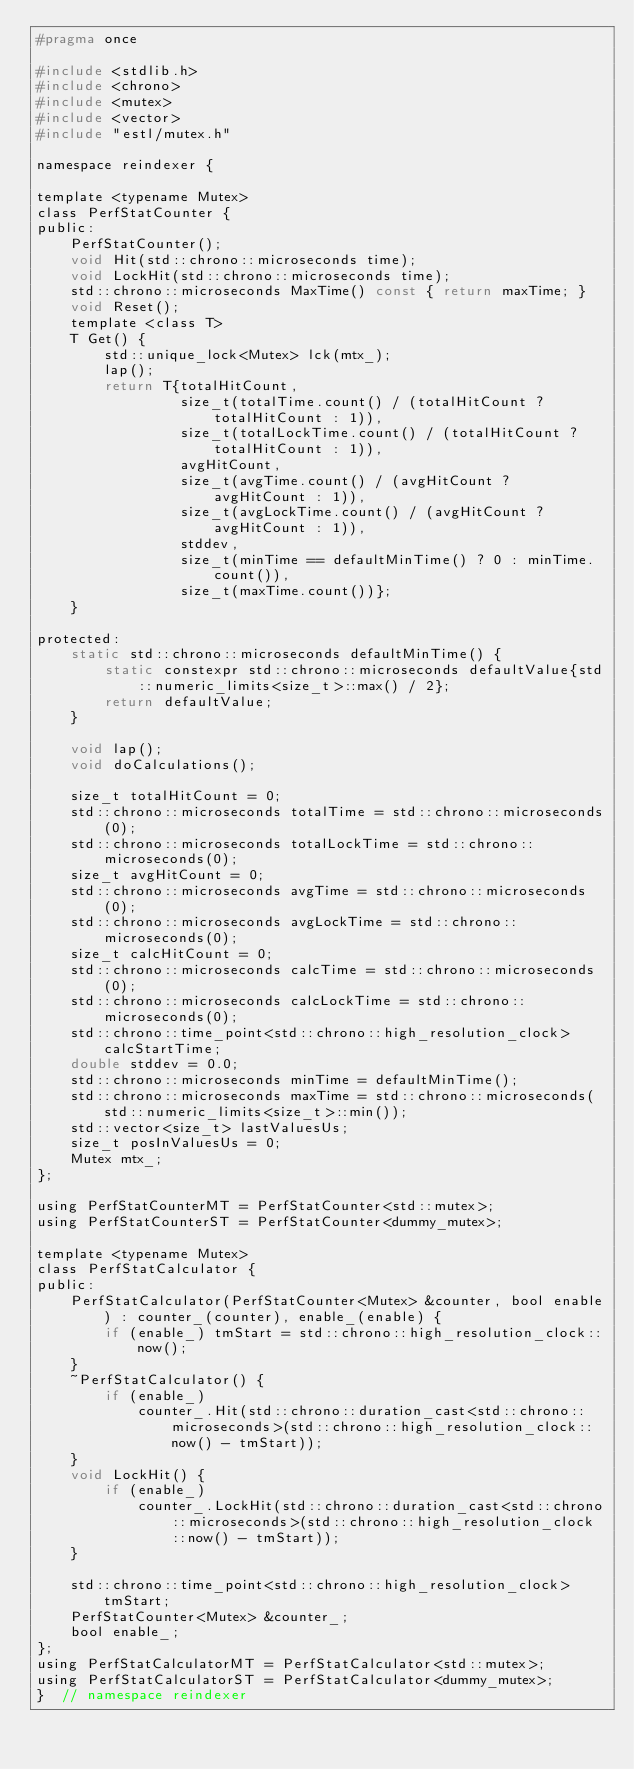Convert code to text. <code><loc_0><loc_0><loc_500><loc_500><_C_>#pragma once

#include <stdlib.h>
#include <chrono>
#include <mutex>
#include <vector>
#include "estl/mutex.h"

namespace reindexer {

template <typename Mutex>
class PerfStatCounter {
public:
	PerfStatCounter();
	void Hit(std::chrono::microseconds time);
	void LockHit(std::chrono::microseconds time);
	std::chrono::microseconds MaxTime() const { return maxTime; }
	void Reset();
	template <class T>
	T Get() {
		std::unique_lock<Mutex> lck(mtx_);
		lap();
		return T{totalHitCount,
				 size_t(totalTime.count() / (totalHitCount ? totalHitCount : 1)),
				 size_t(totalLockTime.count() / (totalHitCount ? totalHitCount : 1)),
				 avgHitCount,
				 size_t(avgTime.count() / (avgHitCount ? avgHitCount : 1)),
				 size_t(avgLockTime.count() / (avgHitCount ? avgHitCount : 1)),
				 stddev,
				 size_t(minTime == defaultMinTime() ? 0 : minTime.count()),
				 size_t(maxTime.count())};
	}

protected:
	static std::chrono::microseconds defaultMinTime() {
		static constexpr std::chrono::microseconds defaultValue{std::numeric_limits<size_t>::max() / 2};
		return defaultValue;
	}

	void lap();
	void doCalculations();

	size_t totalHitCount = 0;
	std::chrono::microseconds totalTime = std::chrono::microseconds(0);
	std::chrono::microseconds totalLockTime = std::chrono::microseconds(0);
	size_t avgHitCount = 0;
	std::chrono::microseconds avgTime = std::chrono::microseconds(0);
	std::chrono::microseconds avgLockTime = std::chrono::microseconds(0);
	size_t calcHitCount = 0;
	std::chrono::microseconds calcTime = std::chrono::microseconds(0);
	std::chrono::microseconds calcLockTime = std::chrono::microseconds(0);
	std::chrono::time_point<std::chrono::high_resolution_clock> calcStartTime;
	double stddev = 0.0;
	std::chrono::microseconds minTime = defaultMinTime();
	std::chrono::microseconds maxTime = std::chrono::microseconds(std::numeric_limits<size_t>::min());
	std::vector<size_t> lastValuesUs;
	size_t posInValuesUs = 0;
	Mutex mtx_;
};

using PerfStatCounterMT = PerfStatCounter<std::mutex>;
using PerfStatCounterST = PerfStatCounter<dummy_mutex>;

template <typename Mutex>
class PerfStatCalculator {
public:
	PerfStatCalculator(PerfStatCounter<Mutex> &counter, bool enable) : counter_(counter), enable_(enable) {
		if (enable_) tmStart = std::chrono::high_resolution_clock::now();
	}
	~PerfStatCalculator() {
		if (enable_)
			counter_.Hit(std::chrono::duration_cast<std::chrono::microseconds>(std::chrono::high_resolution_clock::now() - tmStart));
	}
	void LockHit() {
		if (enable_)
			counter_.LockHit(std::chrono::duration_cast<std::chrono::microseconds>(std::chrono::high_resolution_clock::now() - tmStart));
	}

	std::chrono::time_point<std::chrono::high_resolution_clock> tmStart;
	PerfStatCounter<Mutex> &counter_;
	bool enable_;
};
using PerfStatCalculatorMT = PerfStatCalculator<std::mutex>;
using PerfStatCalculatorST = PerfStatCalculator<dummy_mutex>;
}  // namespace reindexer
</code> 